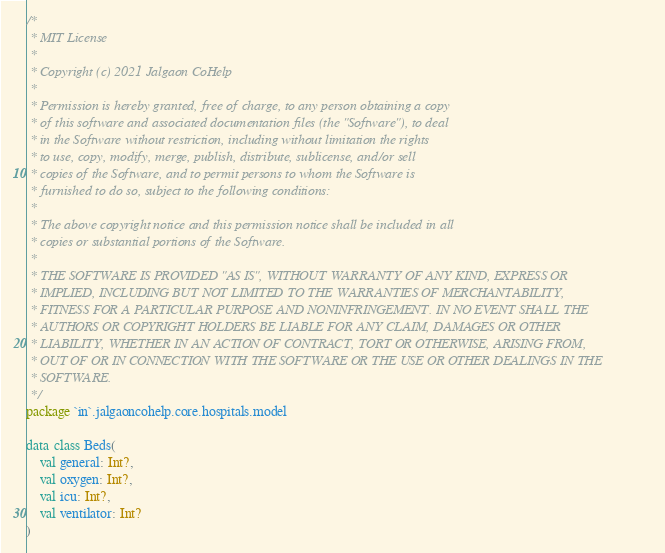Convert code to text. <code><loc_0><loc_0><loc_500><loc_500><_Kotlin_>/*
 * MIT License
 *
 * Copyright (c) 2021 Jalgaon CoHelp
 *
 * Permission is hereby granted, free of charge, to any person obtaining a copy
 * of this software and associated documentation files (the "Software"), to deal
 * in the Software without restriction, including without limitation the rights
 * to use, copy, modify, merge, publish, distribute, sublicense, and/or sell
 * copies of the Software, and to permit persons to whom the Software is
 * furnished to do so, subject to the following conditions:
 *
 * The above copyright notice and this permission notice shall be included in all
 * copies or substantial portions of the Software.
 *
 * THE SOFTWARE IS PROVIDED "AS IS", WITHOUT WARRANTY OF ANY KIND, EXPRESS OR
 * IMPLIED, INCLUDING BUT NOT LIMITED TO THE WARRANTIES OF MERCHANTABILITY,
 * FITNESS FOR A PARTICULAR PURPOSE AND NONINFRINGEMENT. IN NO EVENT SHALL THE
 * AUTHORS OR COPYRIGHT HOLDERS BE LIABLE FOR ANY CLAIM, DAMAGES OR OTHER
 * LIABILITY, WHETHER IN AN ACTION OF CONTRACT, TORT OR OTHERWISE, ARISING FROM,
 * OUT OF OR IN CONNECTION WITH THE SOFTWARE OR THE USE OR OTHER DEALINGS IN THE
 * SOFTWARE.
 */
package `in`.jalgaoncohelp.core.hospitals.model

data class Beds(
    val general: Int?,
    val oxygen: Int?,
    val icu: Int?,
    val ventilator: Int?
)
</code> 